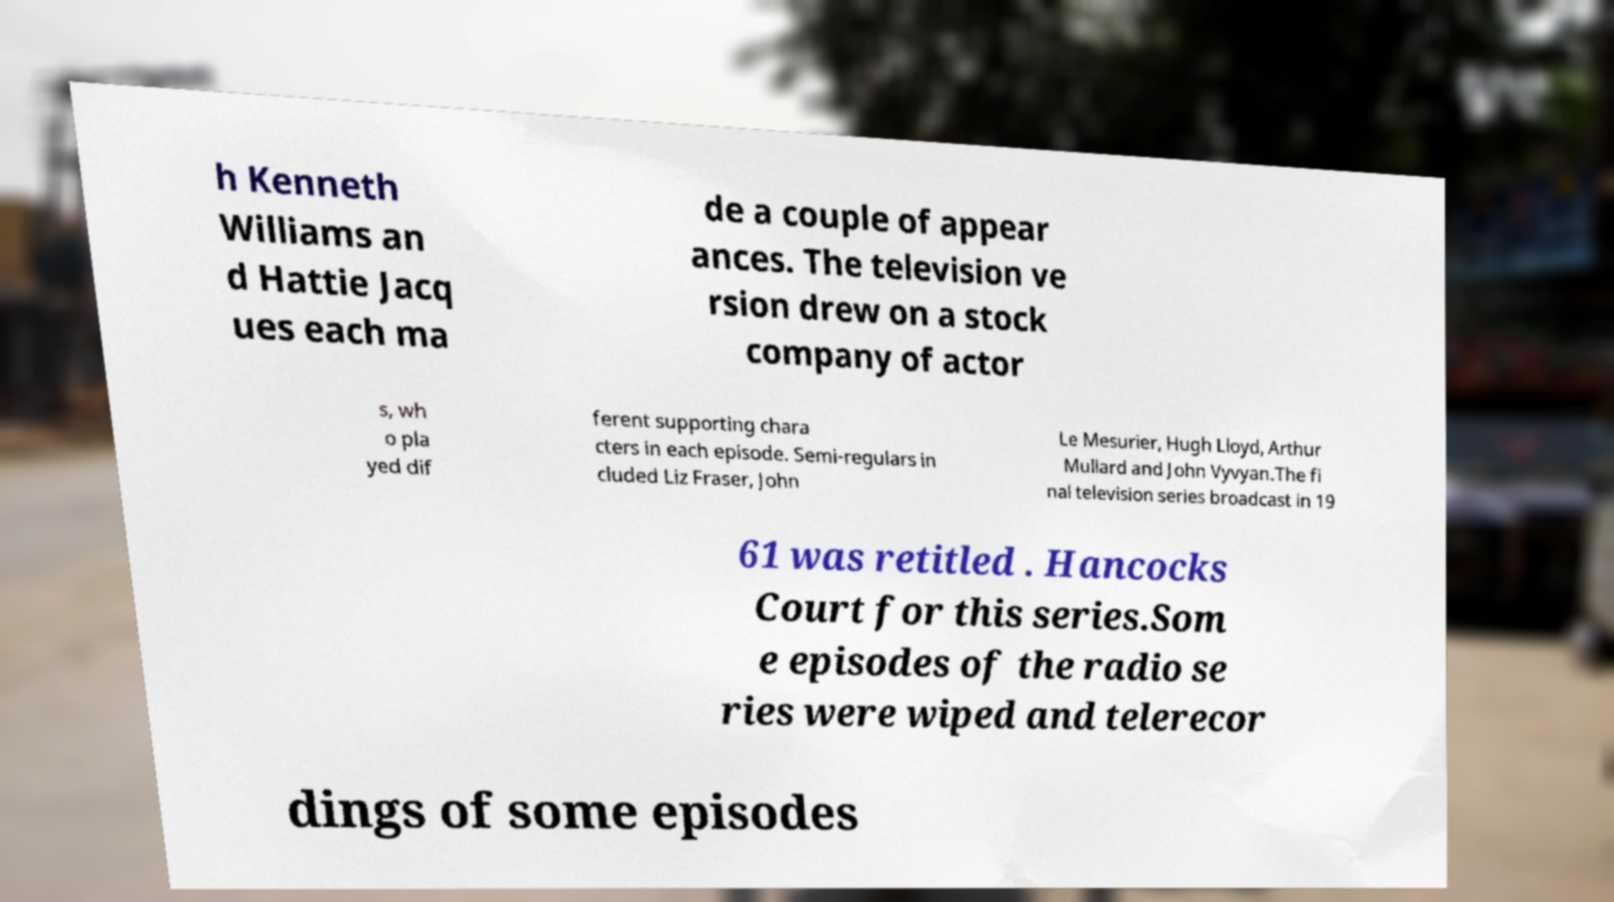For documentation purposes, I need the text within this image transcribed. Could you provide that? h Kenneth Williams an d Hattie Jacq ues each ma de a couple of appear ances. The television ve rsion drew on a stock company of actor s, wh o pla yed dif ferent supporting chara cters in each episode. Semi-regulars in cluded Liz Fraser, John Le Mesurier, Hugh Lloyd, Arthur Mullard and John Vyvyan.The fi nal television series broadcast in 19 61 was retitled . Hancocks Court for this series.Som e episodes of the radio se ries were wiped and telerecor dings of some episodes 